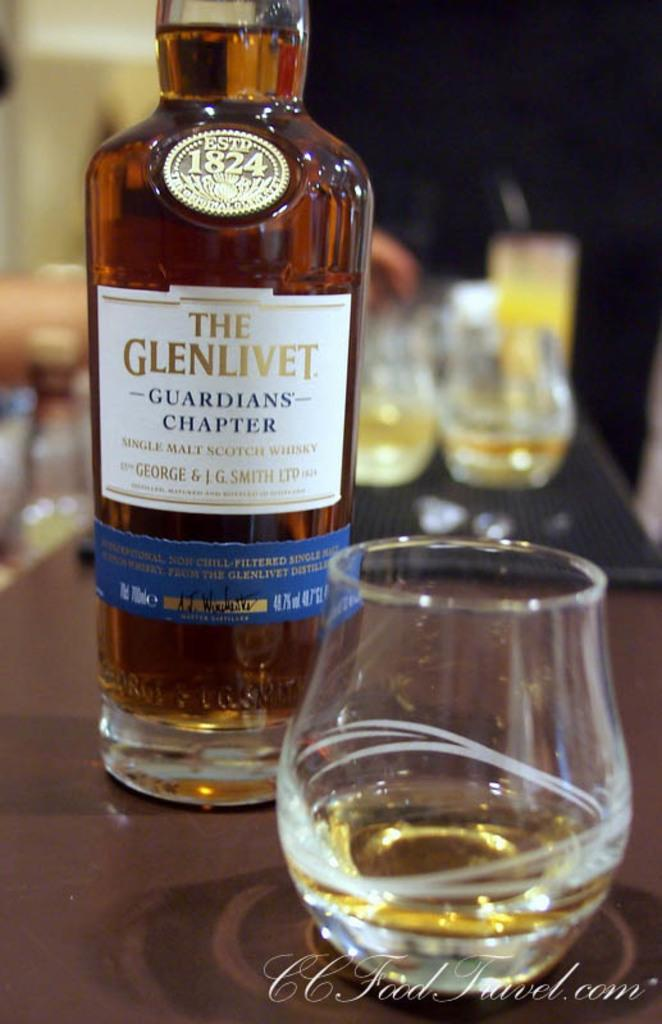What is inside the bottle that is visible in the image? The bottle contains a drink. What else can be seen in the image besides the bottle? There is a glass on a table in the image. Are there any other glasses visible in the image? Yes, there are glasses visible in the background of the image. What type of feather is used to decorate the label on the bottle? There is no feather present on the label of the bottle in the image. Is there an army visible in the image? No, there is no army present in the image. 